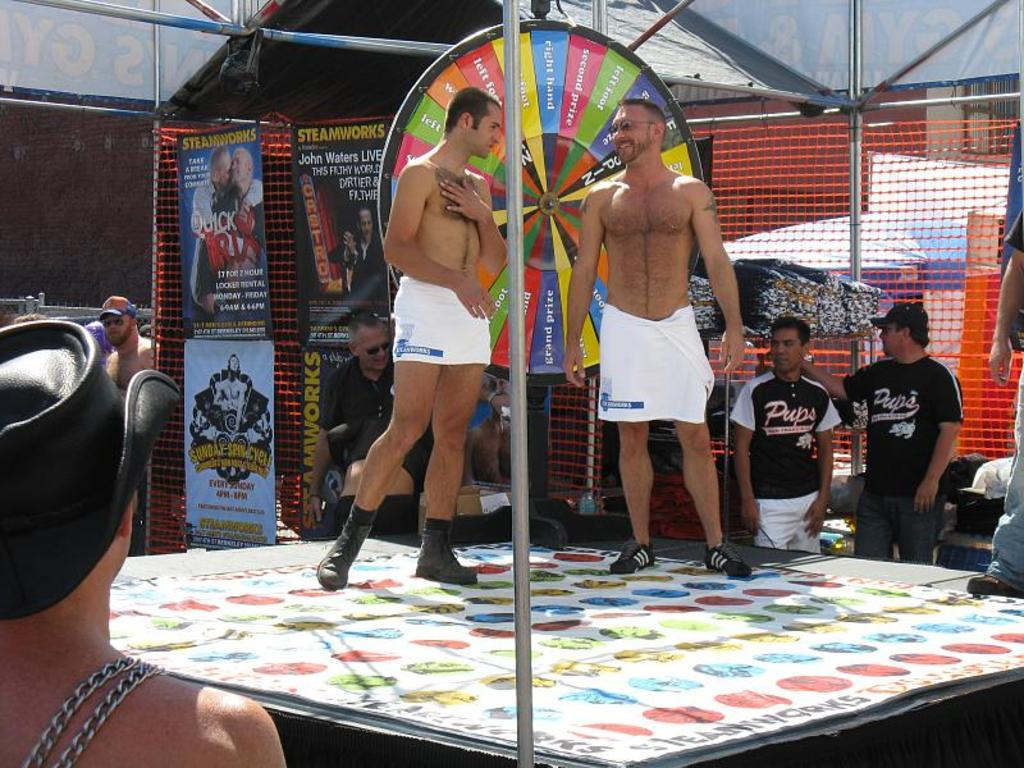Provide a one-sentence caption for the provided image. Two men on a stage wearing white towels in front of Steamworks posters and men in Pups jerseys. 